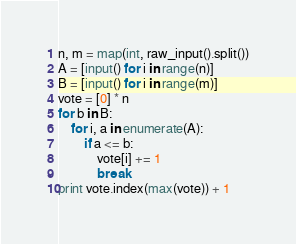Convert code to text. <code><loc_0><loc_0><loc_500><loc_500><_Python_>n, m = map(int, raw_input().split())
A = [input() for i in range(n)]
B = [input() for i in range(m)]
vote = [0] * n
for b in B:
    for i, a in enumerate(A):
        if a <= b:
            vote[i] += 1
            break
print vote.index(max(vote)) + 1</code> 